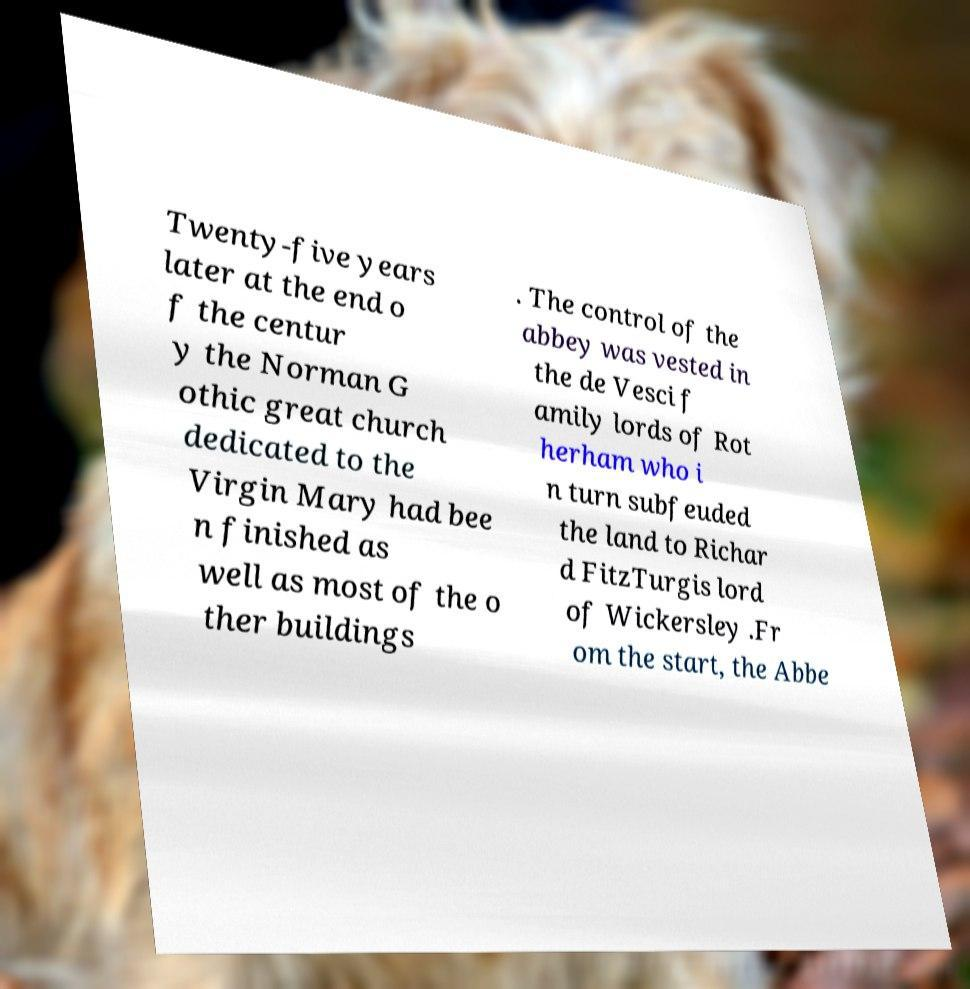Can you read and provide the text displayed in the image?This photo seems to have some interesting text. Can you extract and type it out for me? Twenty-five years later at the end o f the centur y the Norman G othic great church dedicated to the Virgin Mary had bee n finished as well as most of the o ther buildings . The control of the abbey was vested in the de Vesci f amily lords of Rot herham who i n turn subfeuded the land to Richar d FitzTurgis lord of Wickersley .Fr om the start, the Abbe 